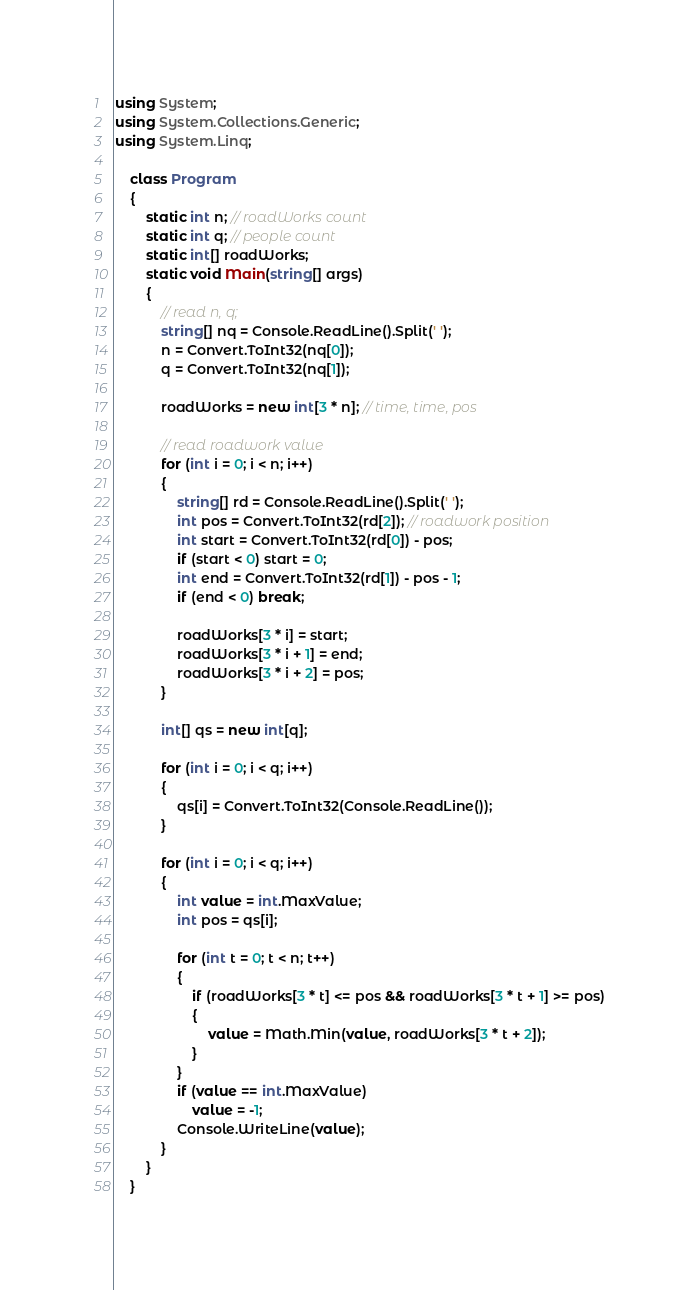<code> <loc_0><loc_0><loc_500><loc_500><_C#_>using System;
using System.Collections.Generic;
using System.Linq;

    class Program
    {
        static int n; // roadWorks count
        static int q; // people count
        static int[] roadWorks;
        static void Main(string[] args)
        {
            // read n, q;
            string[] nq = Console.ReadLine().Split(' ');
            n = Convert.ToInt32(nq[0]);
            q = Convert.ToInt32(nq[1]);

            roadWorks = new int[3 * n]; // time, time, pos

            // read roadwork value
            for (int i = 0; i < n; i++)
            {
                string[] rd = Console.ReadLine().Split(' ');
                int pos = Convert.ToInt32(rd[2]); // roadwork position
                int start = Convert.ToInt32(rd[0]) - pos;
                if (start < 0) start = 0;
                int end = Convert.ToInt32(rd[1]) - pos - 1;
                if (end < 0) break;

                roadWorks[3 * i] = start;
                roadWorks[3 * i + 1] = end;
                roadWorks[3 * i + 2] = pos;
            }

            int[] qs = new int[q];

            for (int i = 0; i < q; i++)
            {
                qs[i] = Convert.ToInt32(Console.ReadLine());
            }

            for (int i = 0; i < q; i++)
            {
                int value = int.MaxValue;
                int pos = qs[i];

                for (int t = 0; t < n; t++)
                {
                    if (roadWorks[3 * t] <= pos && roadWorks[3 * t + 1] >= pos)
                    {
                        value = Math.Min(value, roadWorks[3 * t + 2]);
                    }
                }
                if (value == int.MaxValue)
                    value = -1;
                Console.WriteLine(value);
            }
        }
    }</code> 